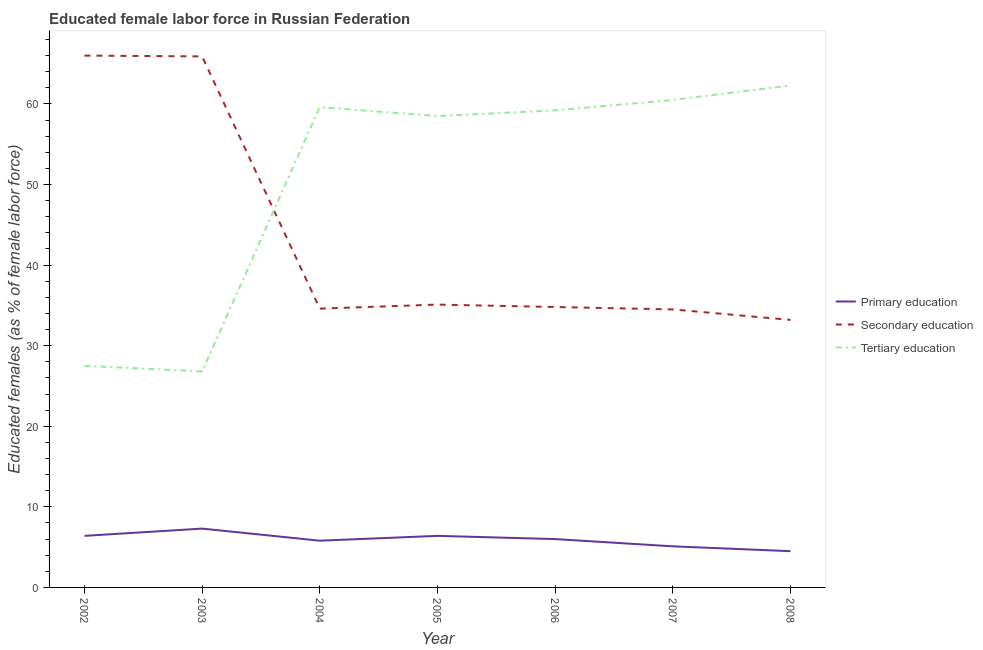Does the line corresponding to percentage of female labor force who received primary education intersect with the line corresponding to percentage of female labor force who received tertiary education?
Ensure brevity in your answer.  No. What is the percentage of female labor force who received primary education in 2008?
Make the answer very short. 4.5. Across all years, what is the maximum percentage of female labor force who received primary education?
Keep it short and to the point. 7.3. What is the total percentage of female labor force who received tertiary education in the graph?
Keep it short and to the point. 354.4. What is the difference between the percentage of female labor force who received primary education in 2003 and that in 2005?
Your answer should be compact. 0.9. What is the difference between the percentage of female labor force who received tertiary education in 2008 and the percentage of female labor force who received secondary education in 2002?
Keep it short and to the point. -3.7. What is the average percentage of female labor force who received tertiary education per year?
Ensure brevity in your answer.  50.63. In the year 2003, what is the difference between the percentage of female labor force who received secondary education and percentage of female labor force who received tertiary education?
Make the answer very short. 39.1. In how many years, is the percentage of female labor force who received secondary education greater than 66 %?
Give a very brief answer. 0. What is the ratio of the percentage of female labor force who received primary education in 2007 to that in 2008?
Your answer should be very brief. 1.13. Is the percentage of female labor force who received secondary education in 2004 less than that in 2008?
Offer a very short reply. No. What is the difference between the highest and the second highest percentage of female labor force who received tertiary education?
Your response must be concise. 1.8. What is the difference between the highest and the lowest percentage of female labor force who received tertiary education?
Offer a very short reply. 35.5. Is it the case that in every year, the sum of the percentage of female labor force who received primary education and percentage of female labor force who received secondary education is greater than the percentage of female labor force who received tertiary education?
Your response must be concise. No. How many lines are there?
Make the answer very short. 3. How many years are there in the graph?
Keep it short and to the point. 7. What is the difference between two consecutive major ticks on the Y-axis?
Provide a short and direct response. 10. Are the values on the major ticks of Y-axis written in scientific E-notation?
Provide a short and direct response. No. Does the graph contain any zero values?
Provide a succinct answer. No. What is the title of the graph?
Give a very brief answer. Educated female labor force in Russian Federation. Does "Transport services" appear as one of the legend labels in the graph?
Keep it short and to the point. No. What is the label or title of the Y-axis?
Offer a terse response. Educated females (as % of female labor force). What is the Educated females (as % of female labor force) in Primary education in 2002?
Provide a succinct answer. 6.4. What is the Educated females (as % of female labor force) of Primary education in 2003?
Your response must be concise. 7.3. What is the Educated females (as % of female labor force) of Secondary education in 2003?
Ensure brevity in your answer.  65.9. What is the Educated females (as % of female labor force) in Tertiary education in 2003?
Your answer should be very brief. 26.8. What is the Educated females (as % of female labor force) of Primary education in 2004?
Offer a terse response. 5.8. What is the Educated females (as % of female labor force) in Secondary education in 2004?
Make the answer very short. 34.6. What is the Educated females (as % of female labor force) in Tertiary education in 2004?
Your answer should be compact. 59.6. What is the Educated females (as % of female labor force) in Primary education in 2005?
Make the answer very short. 6.4. What is the Educated females (as % of female labor force) in Secondary education in 2005?
Provide a short and direct response. 35.1. What is the Educated females (as % of female labor force) of Tertiary education in 2005?
Make the answer very short. 58.5. What is the Educated females (as % of female labor force) in Primary education in 2006?
Provide a short and direct response. 6. What is the Educated females (as % of female labor force) of Secondary education in 2006?
Give a very brief answer. 34.8. What is the Educated females (as % of female labor force) of Tertiary education in 2006?
Ensure brevity in your answer.  59.2. What is the Educated females (as % of female labor force) in Primary education in 2007?
Offer a terse response. 5.1. What is the Educated females (as % of female labor force) in Secondary education in 2007?
Your response must be concise. 34.5. What is the Educated females (as % of female labor force) of Tertiary education in 2007?
Your answer should be compact. 60.5. What is the Educated females (as % of female labor force) of Secondary education in 2008?
Provide a short and direct response. 33.2. What is the Educated females (as % of female labor force) in Tertiary education in 2008?
Your answer should be very brief. 62.3. Across all years, what is the maximum Educated females (as % of female labor force) of Primary education?
Your answer should be very brief. 7.3. Across all years, what is the maximum Educated females (as % of female labor force) in Secondary education?
Your answer should be very brief. 66. Across all years, what is the maximum Educated females (as % of female labor force) of Tertiary education?
Keep it short and to the point. 62.3. Across all years, what is the minimum Educated females (as % of female labor force) in Secondary education?
Your answer should be compact. 33.2. Across all years, what is the minimum Educated females (as % of female labor force) of Tertiary education?
Offer a terse response. 26.8. What is the total Educated females (as % of female labor force) of Primary education in the graph?
Make the answer very short. 41.5. What is the total Educated females (as % of female labor force) in Secondary education in the graph?
Your answer should be very brief. 304.1. What is the total Educated females (as % of female labor force) of Tertiary education in the graph?
Provide a succinct answer. 354.4. What is the difference between the Educated females (as % of female labor force) of Primary education in 2002 and that in 2004?
Offer a very short reply. 0.6. What is the difference between the Educated females (as % of female labor force) of Secondary education in 2002 and that in 2004?
Your answer should be compact. 31.4. What is the difference between the Educated females (as % of female labor force) in Tertiary education in 2002 and that in 2004?
Your answer should be compact. -32.1. What is the difference between the Educated females (as % of female labor force) in Secondary education in 2002 and that in 2005?
Offer a terse response. 30.9. What is the difference between the Educated females (as % of female labor force) of Tertiary education in 2002 and that in 2005?
Provide a short and direct response. -31. What is the difference between the Educated females (as % of female labor force) in Secondary education in 2002 and that in 2006?
Provide a short and direct response. 31.2. What is the difference between the Educated females (as % of female labor force) in Tertiary education in 2002 and that in 2006?
Your response must be concise. -31.7. What is the difference between the Educated females (as % of female labor force) of Secondary education in 2002 and that in 2007?
Provide a succinct answer. 31.5. What is the difference between the Educated females (as % of female labor force) in Tertiary education in 2002 and that in 2007?
Ensure brevity in your answer.  -33. What is the difference between the Educated females (as % of female labor force) of Secondary education in 2002 and that in 2008?
Keep it short and to the point. 32.8. What is the difference between the Educated females (as % of female labor force) of Tertiary education in 2002 and that in 2008?
Make the answer very short. -34.8. What is the difference between the Educated females (as % of female labor force) in Primary education in 2003 and that in 2004?
Provide a short and direct response. 1.5. What is the difference between the Educated females (as % of female labor force) in Secondary education in 2003 and that in 2004?
Provide a short and direct response. 31.3. What is the difference between the Educated females (as % of female labor force) in Tertiary education in 2003 and that in 2004?
Your response must be concise. -32.8. What is the difference between the Educated females (as % of female labor force) of Secondary education in 2003 and that in 2005?
Make the answer very short. 30.8. What is the difference between the Educated females (as % of female labor force) in Tertiary education in 2003 and that in 2005?
Your answer should be compact. -31.7. What is the difference between the Educated females (as % of female labor force) of Primary education in 2003 and that in 2006?
Your answer should be very brief. 1.3. What is the difference between the Educated females (as % of female labor force) of Secondary education in 2003 and that in 2006?
Your answer should be very brief. 31.1. What is the difference between the Educated females (as % of female labor force) of Tertiary education in 2003 and that in 2006?
Provide a succinct answer. -32.4. What is the difference between the Educated females (as % of female labor force) of Secondary education in 2003 and that in 2007?
Offer a very short reply. 31.4. What is the difference between the Educated females (as % of female labor force) in Tertiary education in 2003 and that in 2007?
Offer a very short reply. -33.7. What is the difference between the Educated females (as % of female labor force) of Secondary education in 2003 and that in 2008?
Provide a short and direct response. 32.7. What is the difference between the Educated females (as % of female labor force) of Tertiary education in 2003 and that in 2008?
Offer a terse response. -35.5. What is the difference between the Educated females (as % of female labor force) of Secondary education in 2004 and that in 2005?
Keep it short and to the point. -0.5. What is the difference between the Educated females (as % of female labor force) of Tertiary education in 2004 and that in 2006?
Your response must be concise. 0.4. What is the difference between the Educated females (as % of female labor force) of Secondary education in 2004 and that in 2007?
Provide a short and direct response. 0.1. What is the difference between the Educated females (as % of female labor force) of Secondary education in 2004 and that in 2008?
Keep it short and to the point. 1.4. What is the difference between the Educated females (as % of female labor force) of Primary education in 2005 and that in 2006?
Ensure brevity in your answer.  0.4. What is the difference between the Educated females (as % of female labor force) of Tertiary education in 2005 and that in 2007?
Your answer should be compact. -2. What is the difference between the Educated females (as % of female labor force) in Primary education in 2005 and that in 2008?
Provide a succinct answer. 1.9. What is the difference between the Educated females (as % of female labor force) of Secondary education in 2005 and that in 2008?
Ensure brevity in your answer.  1.9. What is the difference between the Educated females (as % of female labor force) in Tertiary education in 2006 and that in 2007?
Your answer should be very brief. -1.3. What is the difference between the Educated females (as % of female labor force) in Primary education in 2006 and that in 2008?
Provide a short and direct response. 1.5. What is the difference between the Educated females (as % of female labor force) of Secondary education in 2007 and that in 2008?
Provide a short and direct response. 1.3. What is the difference between the Educated females (as % of female labor force) in Primary education in 2002 and the Educated females (as % of female labor force) in Secondary education in 2003?
Your answer should be very brief. -59.5. What is the difference between the Educated females (as % of female labor force) in Primary education in 2002 and the Educated females (as % of female labor force) in Tertiary education in 2003?
Your answer should be very brief. -20.4. What is the difference between the Educated females (as % of female labor force) of Secondary education in 2002 and the Educated females (as % of female labor force) of Tertiary education in 2003?
Ensure brevity in your answer.  39.2. What is the difference between the Educated females (as % of female labor force) of Primary education in 2002 and the Educated females (as % of female labor force) of Secondary education in 2004?
Provide a succinct answer. -28.2. What is the difference between the Educated females (as % of female labor force) of Primary education in 2002 and the Educated females (as % of female labor force) of Tertiary education in 2004?
Offer a very short reply. -53.2. What is the difference between the Educated females (as % of female labor force) in Primary education in 2002 and the Educated females (as % of female labor force) in Secondary education in 2005?
Your response must be concise. -28.7. What is the difference between the Educated females (as % of female labor force) in Primary education in 2002 and the Educated females (as % of female labor force) in Tertiary education in 2005?
Provide a short and direct response. -52.1. What is the difference between the Educated females (as % of female labor force) in Primary education in 2002 and the Educated females (as % of female labor force) in Secondary education in 2006?
Offer a terse response. -28.4. What is the difference between the Educated females (as % of female labor force) of Primary education in 2002 and the Educated females (as % of female labor force) of Tertiary education in 2006?
Your response must be concise. -52.8. What is the difference between the Educated females (as % of female labor force) of Primary education in 2002 and the Educated females (as % of female labor force) of Secondary education in 2007?
Ensure brevity in your answer.  -28.1. What is the difference between the Educated females (as % of female labor force) of Primary education in 2002 and the Educated females (as % of female labor force) of Tertiary education in 2007?
Give a very brief answer. -54.1. What is the difference between the Educated females (as % of female labor force) of Primary education in 2002 and the Educated females (as % of female labor force) of Secondary education in 2008?
Your response must be concise. -26.8. What is the difference between the Educated females (as % of female labor force) of Primary education in 2002 and the Educated females (as % of female labor force) of Tertiary education in 2008?
Your answer should be very brief. -55.9. What is the difference between the Educated females (as % of female labor force) in Secondary education in 2002 and the Educated females (as % of female labor force) in Tertiary education in 2008?
Your answer should be very brief. 3.7. What is the difference between the Educated females (as % of female labor force) of Primary education in 2003 and the Educated females (as % of female labor force) of Secondary education in 2004?
Make the answer very short. -27.3. What is the difference between the Educated females (as % of female labor force) of Primary education in 2003 and the Educated females (as % of female labor force) of Tertiary education in 2004?
Your answer should be very brief. -52.3. What is the difference between the Educated females (as % of female labor force) in Primary education in 2003 and the Educated females (as % of female labor force) in Secondary education in 2005?
Provide a short and direct response. -27.8. What is the difference between the Educated females (as % of female labor force) of Primary education in 2003 and the Educated females (as % of female labor force) of Tertiary education in 2005?
Your answer should be compact. -51.2. What is the difference between the Educated females (as % of female labor force) of Primary education in 2003 and the Educated females (as % of female labor force) of Secondary education in 2006?
Ensure brevity in your answer.  -27.5. What is the difference between the Educated females (as % of female labor force) of Primary education in 2003 and the Educated females (as % of female labor force) of Tertiary education in 2006?
Offer a terse response. -51.9. What is the difference between the Educated females (as % of female labor force) in Secondary education in 2003 and the Educated females (as % of female labor force) in Tertiary education in 2006?
Your answer should be compact. 6.7. What is the difference between the Educated females (as % of female labor force) in Primary education in 2003 and the Educated females (as % of female labor force) in Secondary education in 2007?
Give a very brief answer. -27.2. What is the difference between the Educated females (as % of female labor force) of Primary education in 2003 and the Educated females (as % of female labor force) of Tertiary education in 2007?
Provide a succinct answer. -53.2. What is the difference between the Educated females (as % of female labor force) of Primary education in 2003 and the Educated females (as % of female labor force) of Secondary education in 2008?
Offer a terse response. -25.9. What is the difference between the Educated females (as % of female labor force) of Primary education in 2003 and the Educated females (as % of female labor force) of Tertiary education in 2008?
Provide a succinct answer. -55. What is the difference between the Educated females (as % of female labor force) in Primary education in 2004 and the Educated females (as % of female labor force) in Secondary education in 2005?
Ensure brevity in your answer.  -29.3. What is the difference between the Educated females (as % of female labor force) in Primary education in 2004 and the Educated females (as % of female labor force) in Tertiary education in 2005?
Give a very brief answer. -52.7. What is the difference between the Educated females (as % of female labor force) of Secondary education in 2004 and the Educated females (as % of female labor force) of Tertiary education in 2005?
Provide a succinct answer. -23.9. What is the difference between the Educated females (as % of female labor force) of Primary education in 2004 and the Educated females (as % of female labor force) of Secondary education in 2006?
Your response must be concise. -29. What is the difference between the Educated females (as % of female labor force) of Primary education in 2004 and the Educated females (as % of female labor force) of Tertiary education in 2006?
Provide a succinct answer. -53.4. What is the difference between the Educated females (as % of female labor force) of Secondary education in 2004 and the Educated females (as % of female labor force) of Tertiary education in 2006?
Provide a short and direct response. -24.6. What is the difference between the Educated females (as % of female labor force) in Primary education in 2004 and the Educated females (as % of female labor force) in Secondary education in 2007?
Ensure brevity in your answer.  -28.7. What is the difference between the Educated females (as % of female labor force) of Primary education in 2004 and the Educated females (as % of female labor force) of Tertiary education in 2007?
Offer a terse response. -54.7. What is the difference between the Educated females (as % of female labor force) of Secondary education in 2004 and the Educated females (as % of female labor force) of Tertiary education in 2007?
Offer a terse response. -25.9. What is the difference between the Educated females (as % of female labor force) in Primary education in 2004 and the Educated females (as % of female labor force) in Secondary education in 2008?
Your answer should be compact. -27.4. What is the difference between the Educated females (as % of female labor force) in Primary education in 2004 and the Educated females (as % of female labor force) in Tertiary education in 2008?
Ensure brevity in your answer.  -56.5. What is the difference between the Educated females (as % of female labor force) of Secondary education in 2004 and the Educated females (as % of female labor force) of Tertiary education in 2008?
Your response must be concise. -27.7. What is the difference between the Educated females (as % of female labor force) in Primary education in 2005 and the Educated females (as % of female labor force) in Secondary education in 2006?
Provide a succinct answer. -28.4. What is the difference between the Educated females (as % of female labor force) of Primary education in 2005 and the Educated females (as % of female labor force) of Tertiary education in 2006?
Ensure brevity in your answer.  -52.8. What is the difference between the Educated females (as % of female labor force) of Secondary education in 2005 and the Educated females (as % of female labor force) of Tertiary education in 2006?
Offer a very short reply. -24.1. What is the difference between the Educated females (as % of female labor force) in Primary education in 2005 and the Educated females (as % of female labor force) in Secondary education in 2007?
Offer a very short reply. -28.1. What is the difference between the Educated females (as % of female labor force) in Primary education in 2005 and the Educated females (as % of female labor force) in Tertiary education in 2007?
Offer a terse response. -54.1. What is the difference between the Educated females (as % of female labor force) of Secondary education in 2005 and the Educated females (as % of female labor force) of Tertiary education in 2007?
Your answer should be compact. -25.4. What is the difference between the Educated females (as % of female labor force) in Primary education in 2005 and the Educated females (as % of female labor force) in Secondary education in 2008?
Keep it short and to the point. -26.8. What is the difference between the Educated females (as % of female labor force) in Primary education in 2005 and the Educated females (as % of female labor force) in Tertiary education in 2008?
Keep it short and to the point. -55.9. What is the difference between the Educated females (as % of female labor force) of Secondary education in 2005 and the Educated females (as % of female labor force) of Tertiary education in 2008?
Your answer should be compact. -27.2. What is the difference between the Educated females (as % of female labor force) in Primary education in 2006 and the Educated females (as % of female labor force) in Secondary education in 2007?
Offer a terse response. -28.5. What is the difference between the Educated females (as % of female labor force) in Primary education in 2006 and the Educated females (as % of female labor force) in Tertiary education in 2007?
Your answer should be compact. -54.5. What is the difference between the Educated females (as % of female labor force) in Secondary education in 2006 and the Educated females (as % of female labor force) in Tertiary education in 2007?
Make the answer very short. -25.7. What is the difference between the Educated females (as % of female labor force) of Primary education in 2006 and the Educated females (as % of female labor force) of Secondary education in 2008?
Make the answer very short. -27.2. What is the difference between the Educated females (as % of female labor force) in Primary education in 2006 and the Educated females (as % of female labor force) in Tertiary education in 2008?
Ensure brevity in your answer.  -56.3. What is the difference between the Educated females (as % of female labor force) of Secondary education in 2006 and the Educated females (as % of female labor force) of Tertiary education in 2008?
Ensure brevity in your answer.  -27.5. What is the difference between the Educated females (as % of female labor force) of Primary education in 2007 and the Educated females (as % of female labor force) of Secondary education in 2008?
Your response must be concise. -28.1. What is the difference between the Educated females (as % of female labor force) of Primary education in 2007 and the Educated females (as % of female labor force) of Tertiary education in 2008?
Ensure brevity in your answer.  -57.2. What is the difference between the Educated females (as % of female labor force) of Secondary education in 2007 and the Educated females (as % of female labor force) of Tertiary education in 2008?
Your answer should be very brief. -27.8. What is the average Educated females (as % of female labor force) in Primary education per year?
Your response must be concise. 5.93. What is the average Educated females (as % of female labor force) of Secondary education per year?
Your response must be concise. 43.44. What is the average Educated females (as % of female labor force) of Tertiary education per year?
Provide a short and direct response. 50.63. In the year 2002, what is the difference between the Educated females (as % of female labor force) in Primary education and Educated females (as % of female labor force) in Secondary education?
Offer a very short reply. -59.6. In the year 2002, what is the difference between the Educated females (as % of female labor force) in Primary education and Educated females (as % of female labor force) in Tertiary education?
Provide a succinct answer. -21.1. In the year 2002, what is the difference between the Educated females (as % of female labor force) in Secondary education and Educated females (as % of female labor force) in Tertiary education?
Provide a short and direct response. 38.5. In the year 2003, what is the difference between the Educated females (as % of female labor force) of Primary education and Educated females (as % of female labor force) of Secondary education?
Your answer should be very brief. -58.6. In the year 2003, what is the difference between the Educated females (as % of female labor force) of Primary education and Educated females (as % of female labor force) of Tertiary education?
Provide a succinct answer. -19.5. In the year 2003, what is the difference between the Educated females (as % of female labor force) of Secondary education and Educated females (as % of female labor force) of Tertiary education?
Provide a short and direct response. 39.1. In the year 2004, what is the difference between the Educated females (as % of female labor force) of Primary education and Educated females (as % of female labor force) of Secondary education?
Your answer should be very brief. -28.8. In the year 2004, what is the difference between the Educated females (as % of female labor force) of Primary education and Educated females (as % of female labor force) of Tertiary education?
Give a very brief answer. -53.8. In the year 2004, what is the difference between the Educated females (as % of female labor force) in Secondary education and Educated females (as % of female labor force) in Tertiary education?
Offer a very short reply. -25. In the year 2005, what is the difference between the Educated females (as % of female labor force) of Primary education and Educated females (as % of female labor force) of Secondary education?
Provide a succinct answer. -28.7. In the year 2005, what is the difference between the Educated females (as % of female labor force) in Primary education and Educated females (as % of female labor force) in Tertiary education?
Ensure brevity in your answer.  -52.1. In the year 2005, what is the difference between the Educated females (as % of female labor force) of Secondary education and Educated females (as % of female labor force) of Tertiary education?
Ensure brevity in your answer.  -23.4. In the year 2006, what is the difference between the Educated females (as % of female labor force) in Primary education and Educated females (as % of female labor force) in Secondary education?
Offer a terse response. -28.8. In the year 2006, what is the difference between the Educated females (as % of female labor force) of Primary education and Educated females (as % of female labor force) of Tertiary education?
Your answer should be very brief. -53.2. In the year 2006, what is the difference between the Educated females (as % of female labor force) of Secondary education and Educated females (as % of female labor force) of Tertiary education?
Ensure brevity in your answer.  -24.4. In the year 2007, what is the difference between the Educated females (as % of female labor force) of Primary education and Educated females (as % of female labor force) of Secondary education?
Your answer should be compact. -29.4. In the year 2007, what is the difference between the Educated females (as % of female labor force) in Primary education and Educated females (as % of female labor force) in Tertiary education?
Keep it short and to the point. -55.4. In the year 2008, what is the difference between the Educated females (as % of female labor force) of Primary education and Educated females (as % of female labor force) of Secondary education?
Offer a terse response. -28.7. In the year 2008, what is the difference between the Educated females (as % of female labor force) in Primary education and Educated females (as % of female labor force) in Tertiary education?
Your answer should be compact. -57.8. In the year 2008, what is the difference between the Educated females (as % of female labor force) of Secondary education and Educated females (as % of female labor force) of Tertiary education?
Offer a very short reply. -29.1. What is the ratio of the Educated females (as % of female labor force) in Primary education in 2002 to that in 2003?
Offer a terse response. 0.88. What is the ratio of the Educated females (as % of female labor force) in Secondary education in 2002 to that in 2003?
Make the answer very short. 1. What is the ratio of the Educated females (as % of female labor force) of Tertiary education in 2002 to that in 2003?
Your answer should be very brief. 1.03. What is the ratio of the Educated females (as % of female labor force) of Primary education in 2002 to that in 2004?
Your response must be concise. 1.1. What is the ratio of the Educated females (as % of female labor force) of Secondary education in 2002 to that in 2004?
Offer a very short reply. 1.91. What is the ratio of the Educated females (as % of female labor force) in Tertiary education in 2002 to that in 2004?
Your answer should be very brief. 0.46. What is the ratio of the Educated females (as % of female labor force) of Primary education in 2002 to that in 2005?
Give a very brief answer. 1. What is the ratio of the Educated females (as % of female labor force) in Secondary education in 2002 to that in 2005?
Provide a short and direct response. 1.88. What is the ratio of the Educated females (as % of female labor force) of Tertiary education in 2002 to that in 2005?
Give a very brief answer. 0.47. What is the ratio of the Educated females (as % of female labor force) of Primary education in 2002 to that in 2006?
Keep it short and to the point. 1.07. What is the ratio of the Educated females (as % of female labor force) in Secondary education in 2002 to that in 2006?
Offer a very short reply. 1.9. What is the ratio of the Educated females (as % of female labor force) of Tertiary education in 2002 to that in 2006?
Provide a short and direct response. 0.46. What is the ratio of the Educated females (as % of female labor force) in Primary education in 2002 to that in 2007?
Keep it short and to the point. 1.25. What is the ratio of the Educated females (as % of female labor force) of Secondary education in 2002 to that in 2007?
Keep it short and to the point. 1.91. What is the ratio of the Educated females (as % of female labor force) of Tertiary education in 2002 to that in 2007?
Ensure brevity in your answer.  0.45. What is the ratio of the Educated females (as % of female labor force) in Primary education in 2002 to that in 2008?
Your answer should be compact. 1.42. What is the ratio of the Educated females (as % of female labor force) in Secondary education in 2002 to that in 2008?
Make the answer very short. 1.99. What is the ratio of the Educated females (as % of female labor force) in Tertiary education in 2002 to that in 2008?
Your answer should be very brief. 0.44. What is the ratio of the Educated females (as % of female labor force) of Primary education in 2003 to that in 2004?
Your response must be concise. 1.26. What is the ratio of the Educated females (as % of female labor force) of Secondary education in 2003 to that in 2004?
Give a very brief answer. 1.9. What is the ratio of the Educated females (as % of female labor force) in Tertiary education in 2003 to that in 2004?
Offer a terse response. 0.45. What is the ratio of the Educated females (as % of female labor force) of Primary education in 2003 to that in 2005?
Provide a succinct answer. 1.14. What is the ratio of the Educated females (as % of female labor force) in Secondary education in 2003 to that in 2005?
Make the answer very short. 1.88. What is the ratio of the Educated females (as % of female labor force) in Tertiary education in 2003 to that in 2005?
Give a very brief answer. 0.46. What is the ratio of the Educated females (as % of female labor force) in Primary education in 2003 to that in 2006?
Your answer should be very brief. 1.22. What is the ratio of the Educated females (as % of female labor force) in Secondary education in 2003 to that in 2006?
Your answer should be very brief. 1.89. What is the ratio of the Educated females (as % of female labor force) of Tertiary education in 2003 to that in 2006?
Provide a succinct answer. 0.45. What is the ratio of the Educated females (as % of female labor force) of Primary education in 2003 to that in 2007?
Your response must be concise. 1.43. What is the ratio of the Educated females (as % of female labor force) in Secondary education in 2003 to that in 2007?
Ensure brevity in your answer.  1.91. What is the ratio of the Educated females (as % of female labor force) of Tertiary education in 2003 to that in 2007?
Provide a succinct answer. 0.44. What is the ratio of the Educated females (as % of female labor force) of Primary education in 2003 to that in 2008?
Keep it short and to the point. 1.62. What is the ratio of the Educated females (as % of female labor force) in Secondary education in 2003 to that in 2008?
Ensure brevity in your answer.  1.98. What is the ratio of the Educated females (as % of female labor force) of Tertiary education in 2003 to that in 2008?
Your response must be concise. 0.43. What is the ratio of the Educated females (as % of female labor force) of Primary education in 2004 to that in 2005?
Offer a very short reply. 0.91. What is the ratio of the Educated females (as % of female labor force) of Secondary education in 2004 to that in 2005?
Offer a terse response. 0.99. What is the ratio of the Educated females (as % of female labor force) of Tertiary education in 2004 to that in 2005?
Your answer should be very brief. 1.02. What is the ratio of the Educated females (as % of female labor force) in Primary education in 2004 to that in 2006?
Provide a succinct answer. 0.97. What is the ratio of the Educated females (as % of female labor force) in Secondary education in 2004 to that in 2006?
Your response must be concise. 0.99. What is the ratio of the Educated females (as % of female labor force) in Tertiary education in 2004 to that in 2006?
Offer a very short reply. 1.01. What is the ratio of the Educated females (as % of female labor force) of Primary education in 2004 to that in 2007?
Ensure brevity in your answer.  1.14. What is the ratio of the Educated females (as % of female labor force) in Secondary education in 2004 to that in 2007?
Your answer should be compact. 1. What is the ratio of the Educated females (as % of female labor force) of Tertiary education in 2004 to that in 2007?
Ensure brevity in your answer.  0.99. What is the ratio of the Educated females (as % of female labor force) of Primary education in 2004 to that in 2008?
Provide a succinct answer. 1.29. What is the ratio of the Educated females (as % of female labor force) in Secondary education in 2004 to that in 2008?
Your response must be concise. 1.04. What is the ratio of the Educated females (as % of female labor force) in Tertiary education in 2004 to that in 2008?
Provide a short and direct response. 0.96. What is the ratio of the Educated females (as % of female labor force) in Primary education in 2005 to that in 2006?
Provide a short and direct response. 1.07. What is the ratio of the Educated females (as % of female labor force) in Secondary education in 2005 to that in 2006?
Provide a succinct answer. 1.01. What is the ratio of the Educated females (as % of female labor force) of Primary education in 2005 to that in 2007?
Your answer should be compact. 1.25. What is the ratio of the Educated females (as % of female labor force) in Secondary education in 2005 to that in 2007?
Provide a succinct answer. 1.02. What is the ratio of the Educated females (as % of female labor force) in Tertiary education in 2005 to that in 2007?
Offer a terse response. 0.97. What is the ratio of the Educated females (as % of female labor force) of Primary education in 2005 to that in 2008?
Offer a terse response. 1.42. What is the ratio of the Educated females (as % of female labor force) in Secondary education in 2005 to that in 2008?
Make the answer very short. 1.06. What is the ratio of the Educated females (as % of female labor force) of Tertiary education in 2005 to that in 2008?
Keep it short and to the point. 0.94. What is the ratio of the Educated females (as % of female labor force) of Primary education in 2006 to that in 2007?
Offer a very short reply. 1.18. What is the ratio of the Educated females (as % of female labor force) of Secondary education in 2006 to that in 2007?
Your response must be concise. 1.01. What is the ratio of the Educated females (as % of female labor force) in Tertiary education in 2006 to that in 2007?
Your response must be concise. 0.98. What is the ratio of the Educated females (as % of female labor force) in Primary education in 2006 to that in 2008?
Provide a succinct answer. 1.33. What is the ratio of the Educated females (as % of female labor force) of Secondary education in 2006 to that in 2008?
Ensure brevity in your answer.  1.05. What is the ratio of the Educated females (as % of female labor force) of Tertiary education in 2006 to that in 2008?
Offer a very short reply. 0.95. What is the ratio of the Educated females (as % of female labor force) in Primary education in 2007 to that in 2008?
Provide a succinct answer. 1.13. What is the ratio of the Educated females (as % of female labor force) in Secondary education in 2007 to that in 2008?
Your response must be concise. 1.04. What is the ratio of the Educated females (as % of female labor force) of Tertiary education in 2007 to that in 2008?
Provide a succinct answer. 0.97. What is the difference between the highest and the second highest Educated females (as % of female labor force) in Primary education?
Provide a succinct answer. 0.9. What is the difference between the highest and the second highest Educated females (as % of female labor force) in Secondary education?
Offer a very short reply. 0.1. What is the difference between the highest and the lowest Educated females (as % of female labor force) in Secondary education?
Your response must be concise. 32.8. What is the difference between the highest and the lowest Educated females (as % of female labor force) in Tertiary education?
Your answer should be very brief. 35.5. 